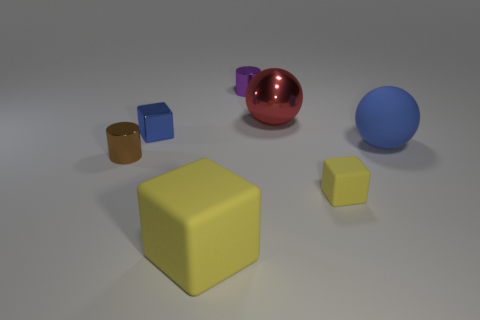Can you tell me which object stands out the most in this image and why? The large yellow cube stands out prominently due to its considerable size relative to the other objects and its bright, vivid color that captures attention against the neutral background. Its central position in the image also draws the viewer's focus to it as a key element of the composition. 